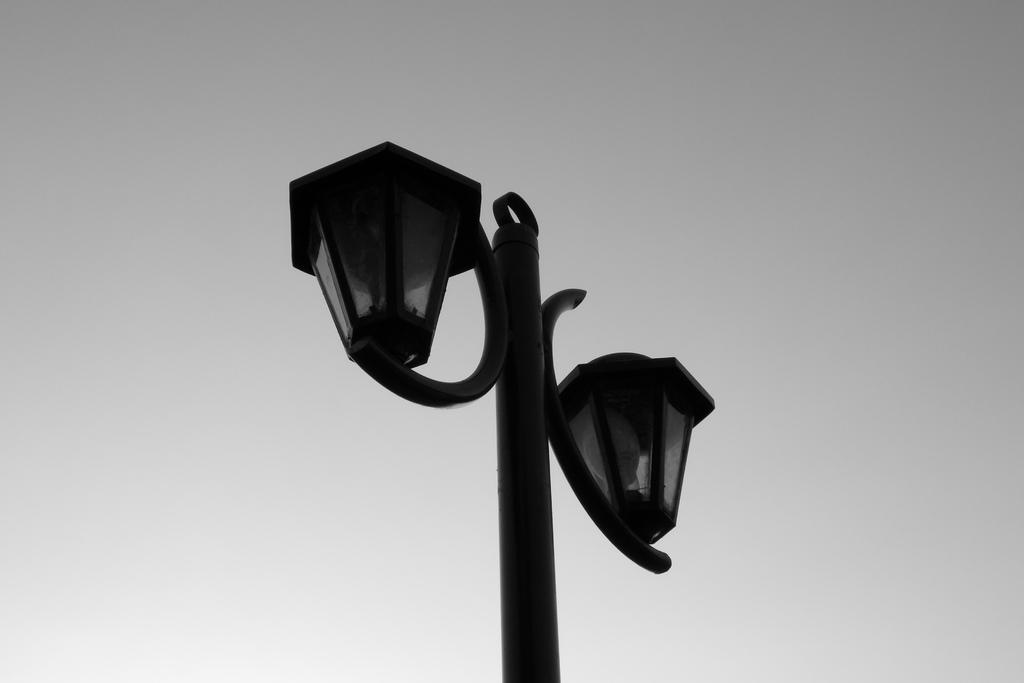What is the main object in the image? There is a pole with lights in the image. What is the color scheme of the image? The image is black and white. What can be seen in the sky in the image? The sky is clear in the image. Can you tell me how many cribs are visible in the image? There are no cribs present in the image; it features a pole with lights. What type of slave is depicted in the image? There is no depiction of a slave in the image; it features a pole with lights. 